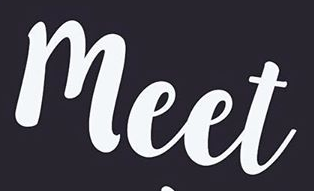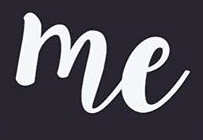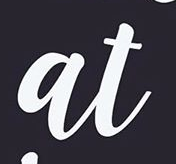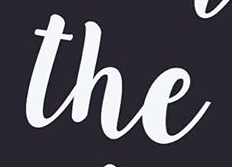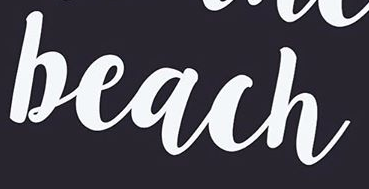Transcribe the words shown in these images in order, separated by a semicolon. meet; me; at; the; beach 